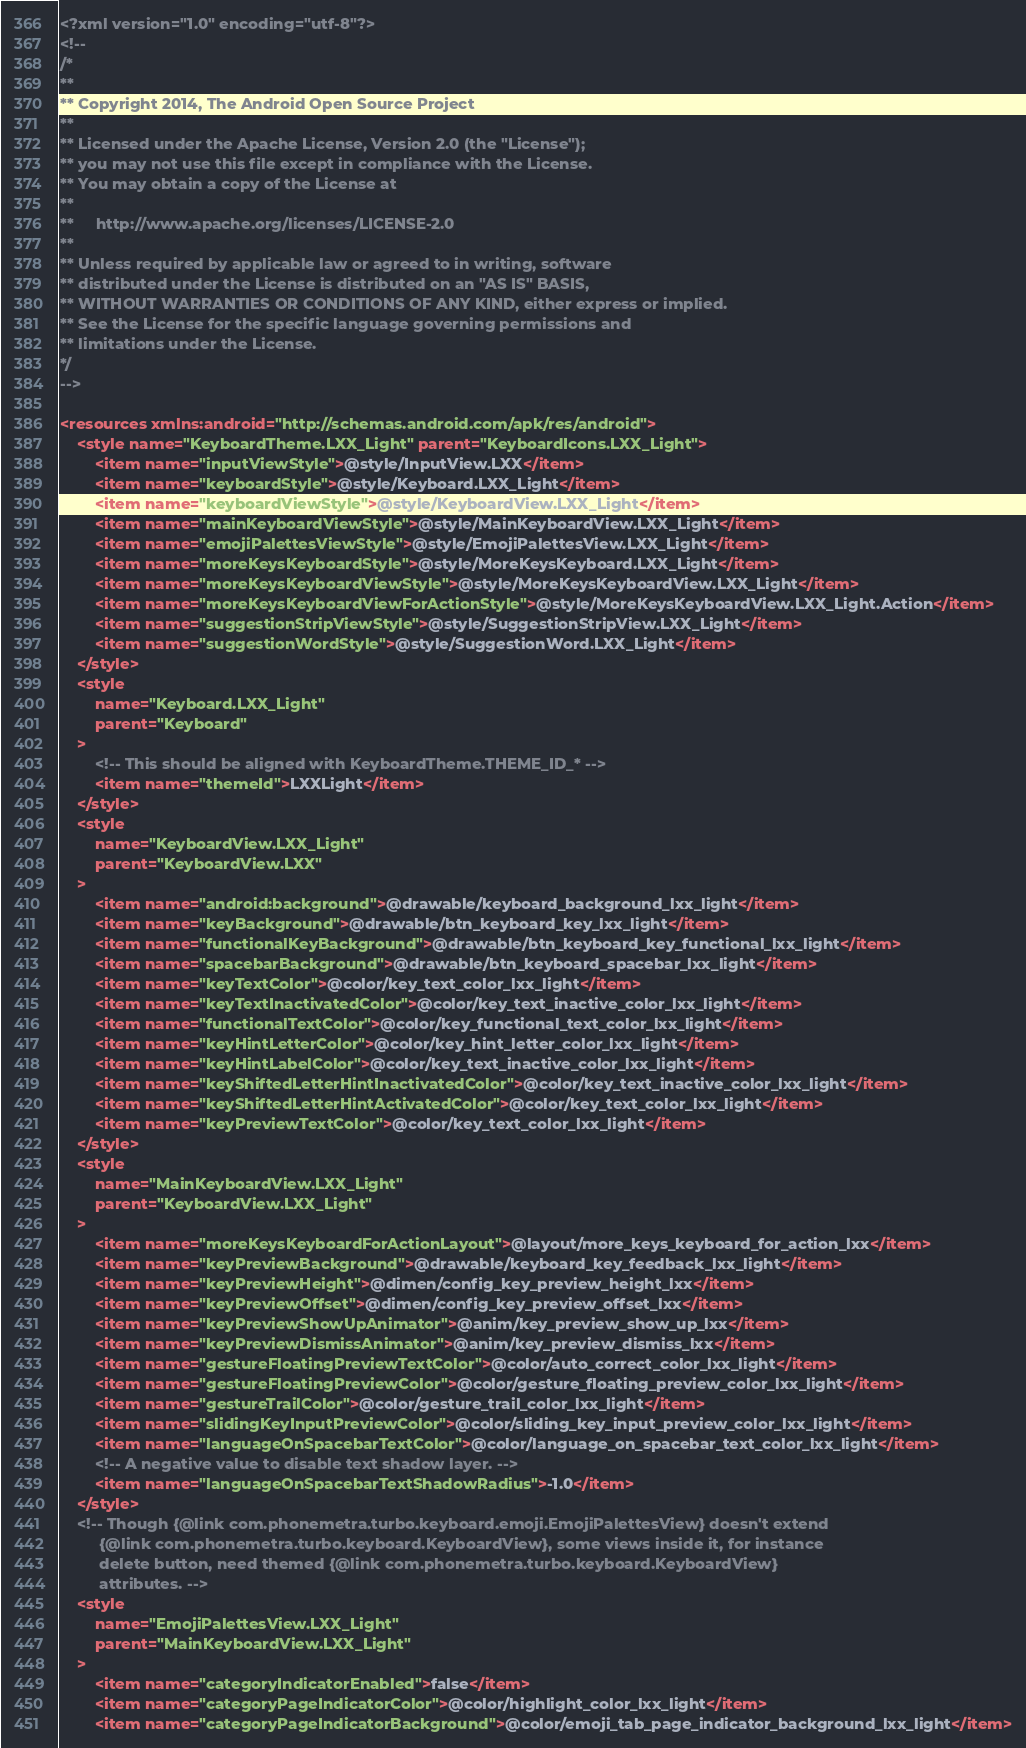<code> <loc_0><loc_0><loc_500><loc_500><_XML_><?xml version="1.0" encoding="utf-8"?>
<!--
/*
**
** Copyright 2014, The Android Open Source Project
**
** Licensed under the Apache License, Version 2.0 (the "License");
** you may not use this file except in compliance with the License.
** You may obtain a copy of the License at
**
**     http://www.apache.org/licenses/LICENSE-2.0
**
** Unless required by applicable law or agreed to in writing, software
** distributed under the License is distributed on an "AS IS" BASIS,
** WITHOUT WARRANTIES OR CONDITIONS OF ANY KIND, either express or implied.
** See the License for the specific language governing permissions and
** limitations under the License.
*/
-->

<resources xmlns:android="http://schemas.android.com/apk/res/android">
    <style name="KeyboardTheme.LXX_Light" parent="KeyboardIcons.LXX_Light">
        <item name="inputViewStyle">@style/InputView.LXX</item>
        <item name="keyboardStyle">@style/Keyboard.LXX_Light</item>
        <item name="keyboardViewStyle">@style/KeyboardView.LXX_Light</item>
        <item name="mainKeyboardViewStyle">@style/MainKeyboardView.LXX_Light</item>
        <item name="emojiPalettesViewStyle">@style/EmojiPalettesView.LXX_Light</item>
        <item name="moreKeysKeyboardStyle">@style/MoreKeysKeyboard.LXX_Light</item>
        <item name="moreKeysKeyboardViewStyle">@style/MoreKeysKeyboardView.LXX_Light</item>
        <item name="moreKeysKeyboardViewForActionStyle">@style/MoreKeysKeyboardView.LXX_Light.Action</item>
        <item name="suggestionStripViewStyle">@style/SuggestionStripView.LXX_Light</item>
        <item name="suggestionWordStyle">@style/SuggestionWord.LXX_Light</item>
    </style>
    <style
        name="Keyboard.LXX_Light"
        parent="Keyboard"
    >
        <!-- This should be aligned with KeyboardTheme.THEME_ID_* -->
        <item name="themeId">LXXLight</item>
    </style>
    <style
        name="KeyboardView.LXX_Light"
        parent="KeyboardView.LXX"
    >
        <item name="android:background">@drawable/keyboard_background_lxx_light</item>
        <item name="keyBackground">@drawable/btn_keyboard_key_lxx_light</item>
        <item name="functionalKeyBackground">@drawable/btn_keyboard_key_functional_lxx_light</item>
        <item name="spacebarBackground">@drawable/btn_keyboard_spacebar_lxx_light</item>
        <item name="keyTextColor">@color/key_text_color_lxx_light</item>
        <item name="keyTextInactivatedColor">@color/key_text_inactive_color_lxx_light</item>
        <item name="functionalTextColor">@color/key_functional_text_color_lxx_light</item>
        <item name="keyHintLetterColor">@color/key_hint_letter_color_lxx_light</item>
        <item name="keyHintLabelColor">@color/key_text_inactive_color_lxx_light</item>
        <item name="keyShiftedLetterHintInactivatedColor">@color/key_text_inactive_color_lxx_light</item>
        <item name="keyShiftedLetterHintActivatedColor">@color/key_text_color_lxx_light</item>
        <item name="keyPreviewTextColor">@color/key_text_color_lxx_light</item>
    </style>
    <style
        name="MainKeyboardView.LXX_Light"
        parent="KeyboardView.LXX_Light"
    >
        <item name="moreKeysKeyboardForActionLayout">@layout/more_keys_keyboard_for_action_lxx</item>
        <item name="keyPreviewBackground">@drawable/keyboard_key_feedback_lxx_light</item>
        <item name="keyPreviewHeight">@dimen/config_key_preview_height_lxx</item>
        <item name="keyPreviewOffset">@dimen/config_key_preview_offset_lxx</item>
        <item name="keyPreviewShowUpAnimator">@anim/key_preview_show_up_lxx</item>
        <item name="keyPreviewDismissAnimator">@anim/key_preview_dismiss_lxx</item>
        <item name="gestureFloatingPreviewTextColor">@color/auto_correct_color_lxx_light</item>
        <item name="gestureFloatingPreviewColor">@color/gesture_floating_preview_color_lxx_light</item>
        <item name="gestureTrailColor">@color/gesture_trail_color_lxx_light</item>
        <item name="slidingKeyInputPreviewColor">@color/sliding_key_input_preview_color_lxx_light</item>
        <item name="languageOnSpacebarTextColor">@color/language_on_spacebar_text_color_lxx_light</item>
        <!-- A negative value to disable text shadow layer. -->
        <item name="languageOnSpacebarTextShadowRadius">-1.0</item>
    </style>
    <!-- Though {@link com.phonemetra.turbo.keyboard.emoji.EmojiPalettesView} doesn't extend
         {@link com.phonemetra.turbo.keyboard.KeyboardView}, some views inside it, for instance
         delete button, need themed {@link com.phonemetra.turbo.keyboard.KeyboardView}
         attributes. -->
    <style
        name="EmojiPalettesView.LXX_Light"
        parent="MainKeyboardView.LXX_Light"
    >
        <item name="categoryIndicatorEnabled">false</item>
        <item name="categoryPageIndicatorColor">@color/highlight_color_lxx_light</item>
        <item name="categoryPageIndicatorBackground">@color/emoji_tab_page_indicator_background_lxx_light</item></code> 